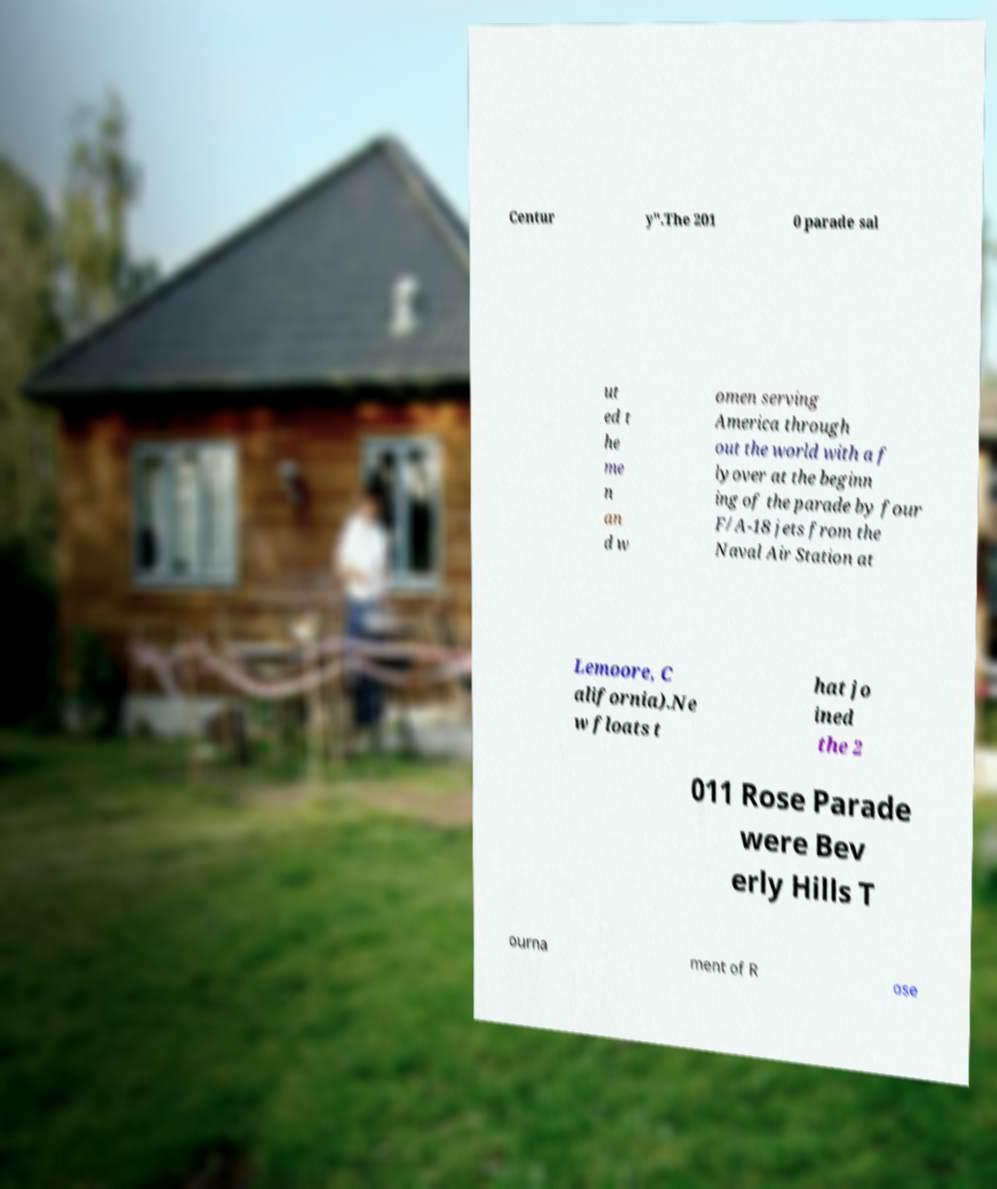Please identify and transcribe the text found in this image. Centur y".The 201 0 parade sal ut ed t he me n an d w omen serving America through out the world with a f lyover at the beginn ing of the parade by four F/A-18 jets from the Naval Air Station at Lemoore, C alifornia).Ne w floats t hat jo ined the 2 011 Rose Parade were Bev erly Hills T ourna ment of R ose 